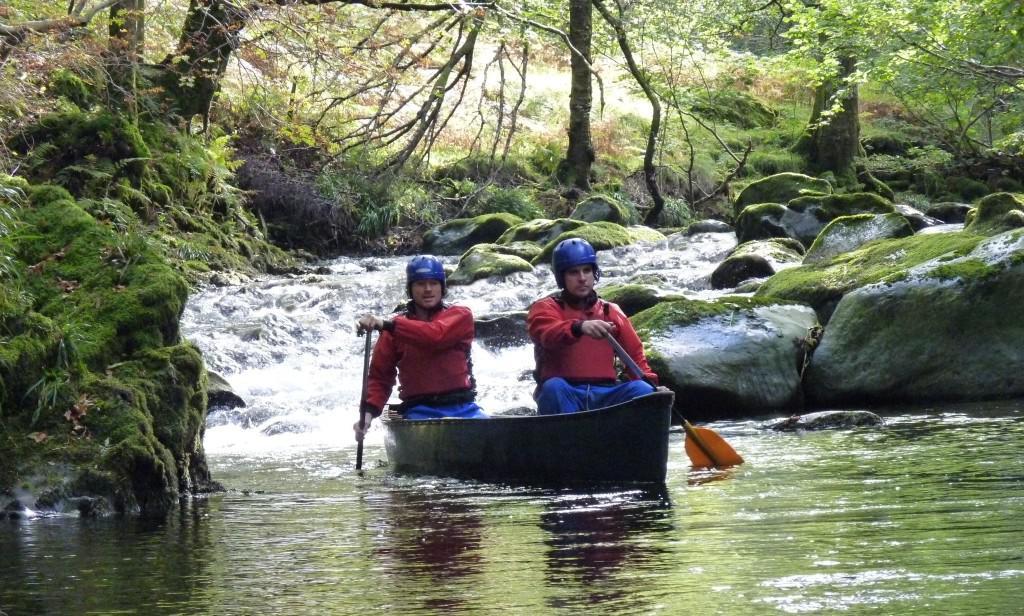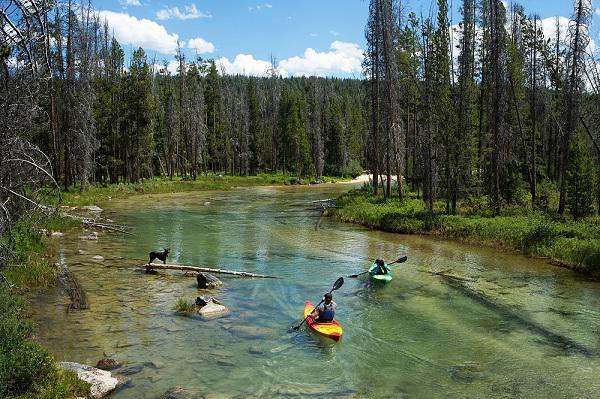The first image is the image on the left, the second image is the image on the right. Evaluate the accuracy of this statement regarding the images: "The left image contains at least one canoe with multiple people in it heading forward on the water.". Is it true? Answer yes or no. Yes. The first image is the image on the left, the second image is the image on the right. Evaluate the accuracy of this statement regarding the images: "in at least one image there are two people sitting on a boat.". Is it true? Answer yes or no. Yes. 